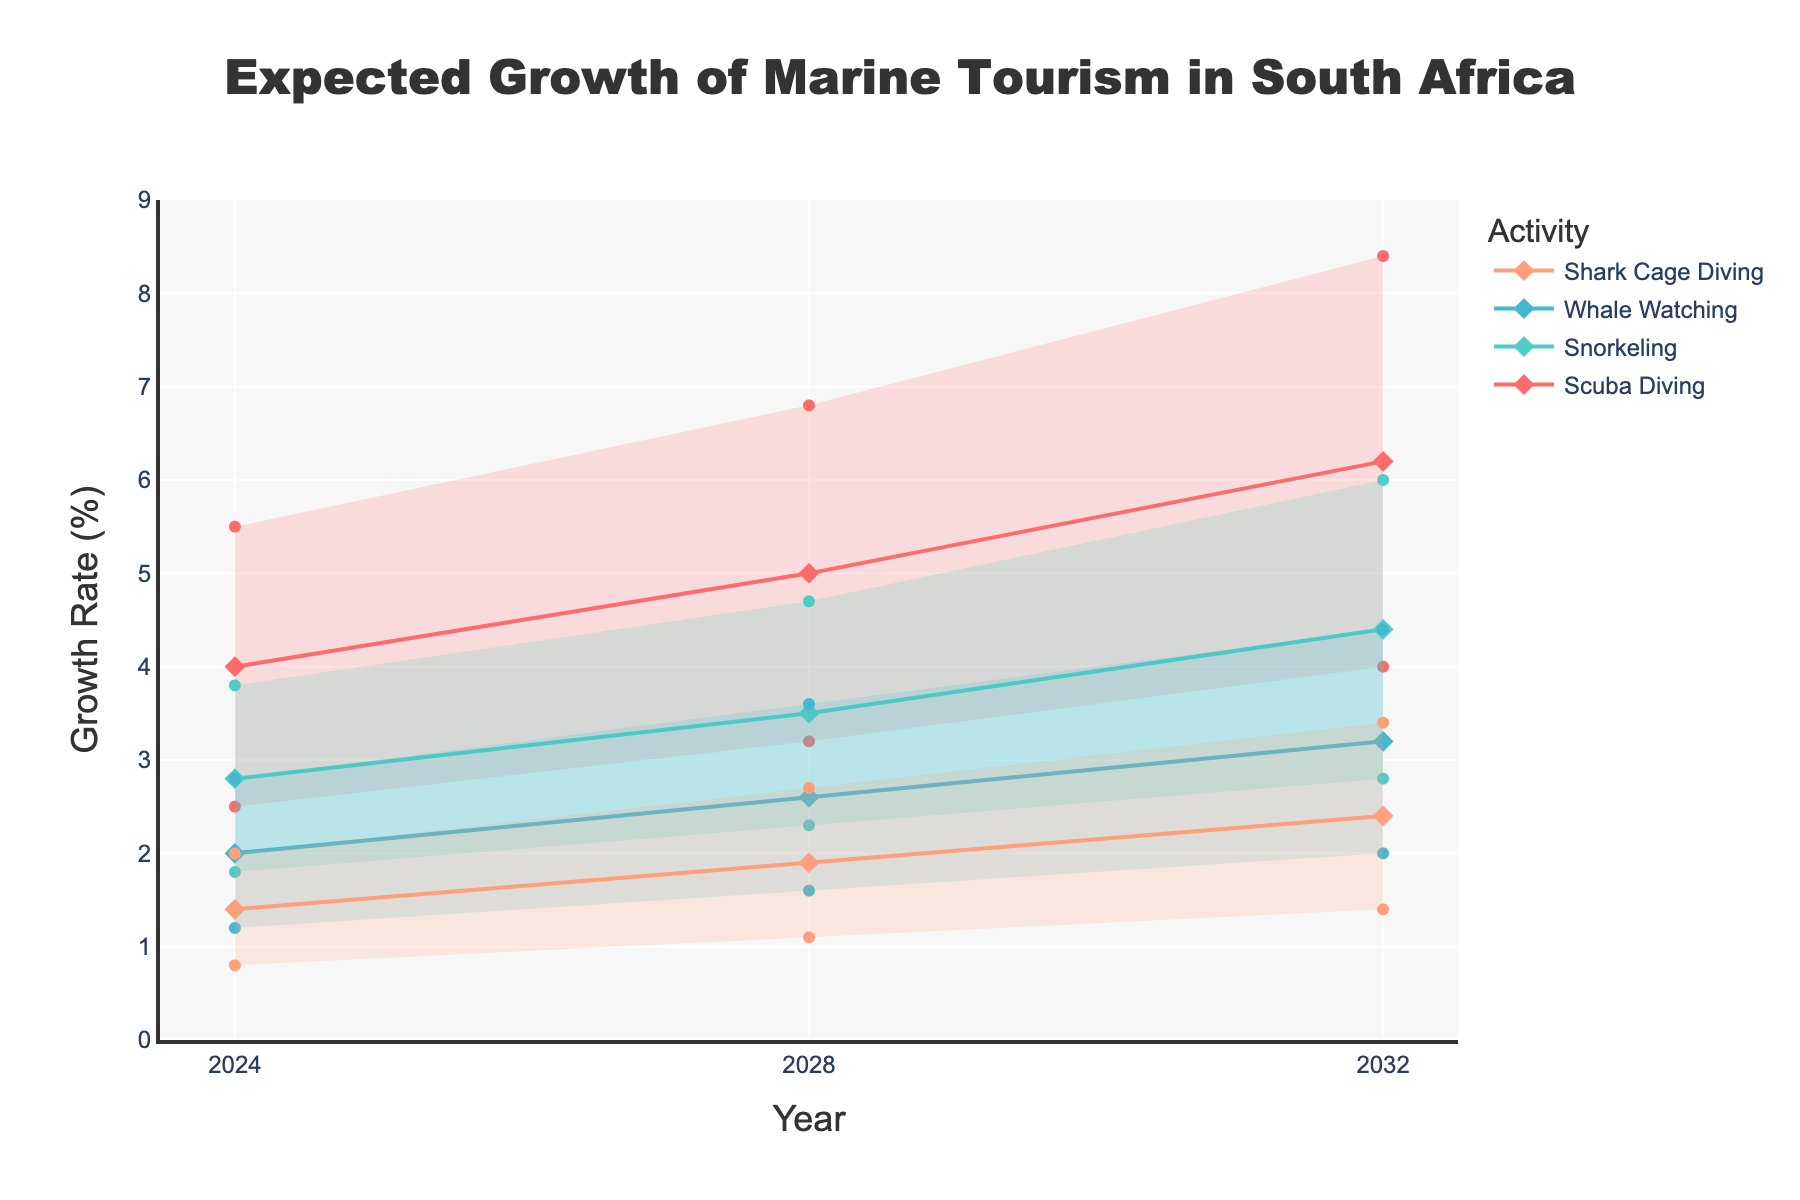What's the title of the chart? The title of the chart is usually indicated at the top and summarizes the main topic. In this case, it's "Expected Growth of Marine Tourism in South Africa".
Answer: Expected Growth of Marine Tourism in South Africa How many activities are displayed in the chart? To determine the number of activities, count the distinct markers or traces in the chart legends or visually distinct lines when colors are different. Here, the activities are Scuba Diving, Snorkeling, Whale Watching, and Shark Cage Diving.
Answer: 4 What is the expected mid growth rate for Scuba Diving in 2028? Identify the trace for Scuba Diving and look for the mid value (the middle line) for the year 2028. From the data table, the value is 5.0.
Answer: 5.0 Which activity has the highest expected mid growth rate in 2032? Compare the mid values for each activity in the year 2032. Scuba Diving has the highest mid growth rate at 6.2.
Answer: Scuba Diving What is the range of expected growth rates for Snorkeling in 2024? To find the range, subtract the Low value from the High value for Snorkeling in 2024. From the data, the range is 3.8 (High) - 1.8 (Low) = 2.0.
Answer: 2.0 How does the mid growth rate of Shark Cage Diving in 2024 compare to that in 2028? Look at the mid growth rates for Shark Cage Diving for the years 2024 and 2028. In 2024, it is 1.4, and in 2028, it is 1.9. There is an increase of 1.9 - 1.4 = 0.5
Answer: It increased by 0.5 What is the average expected low growth rate for Whale Watching across all the years? Calculate the average of the low growth rates for Whale Watching for the years 2024, 2028, and 2032. The values are 1.2, 1.6, and 2.0. The average is (1.2 + 1.6 + 2.0)/3 = 1.6
Answer: 1.6 Which activity shows the smallest expected high growth rate in 2032? Compare the high values for all activities in 2032. Shark Cage Diving has the smallest high growth rate at 3.4.
Answer: Shark Cage Diving What is the trend of the expected mid growth rate for Snorkeling over the years displayed in the chart? Observe the mid growth rate values for Snorkeling in 2024, 2028, and 2032. The values are 2.8, 3.5, and 4.4, respectively, indicating an increasing trend.
Answer: Increasing What is the difference between the high and low expected growth rates for Scuba Diving in 2028? Calculate the difference by subtracting the low value from the high value for Scuba Diving in 2028. From the data, the difference is 6.8 (High) - 3.2 (Low) = 3.6.
Answer: 3.6 